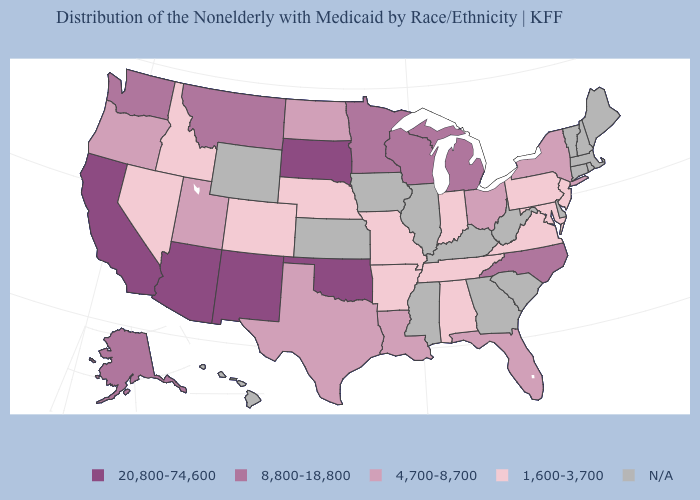Among the states that border Georgia , does Alabama have the lowest value?
Quick response, please. Yes. Which states have the highest value in the USA?
Be succinct. Arizona, California, New Mexico, Oklahoma, South Dakota. Name the states that have a value in the range 8,800-18,800?
Write a very short answer. Alaska, Michigan, Minnesota, Montana, North Carolina, Washington, Wisconsin. Name the states that have a value in the range 4,700-8,700?
Answer briefly. Florida, Louisiana, New York, North Dakota, Ohio, Oregon, Texas, Utah. Does Alabama have the lowest value in the South?
Quick response, please. Yes. How many symbols are there in the legend?
Concise answer only. 5. How many symbols are there in the legend?
Quick response, please. 5. Does the first symbol in the legend represent the smallest category?
Give a very brief answer. No. What is the value of Kansas?
Answer briefly. N/A. How many symbols are there in the legend?
Quick response, please. 5. Which states have the highest value in the USA?
Short answer required. Arizona, California, New Mexico, Oklahoma, South Dakota. Name the states that have a value in the range 8,800-18,800?
Be succinct. Alaska, Michigan, Minnesota, Montana, North Carolina, Washington, Wisconsin. Does the map have missing data?
Be succinct. Yes. What is the highest value in the USA?
Answer briefly. 20,800-74,600. What is the highest value in the USA?
Be succinct. 20,800-74,600. 